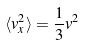<formula> <loc_0><loc_0><loc_500><loc_500>\langle v _ { x } ^ { 2 } \rangle = \frac { 1 } { 3 } v ^ { 2 }</formula> 